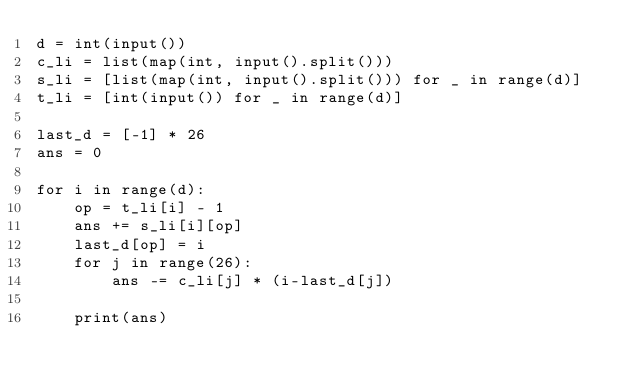<code> <loc_0><loc_0><loc_500><loc_500><_Python_>d = int(input())
c_li = list(map(int, input().split()))
s_li = [list(map(int, input().split())) for _ in range(d)]
t_li = [int(input()) for _ in range(d)]

last_d = [-1] * 26
ans = 0

for i in range(d):
    op = t_li[i] - 1
    ans += s_li[i][op]
    last_d[op] = i
    for j in range(26):
        ans -= c_li[j] * (i-last_d[j])
    
    print(ans)</code> 